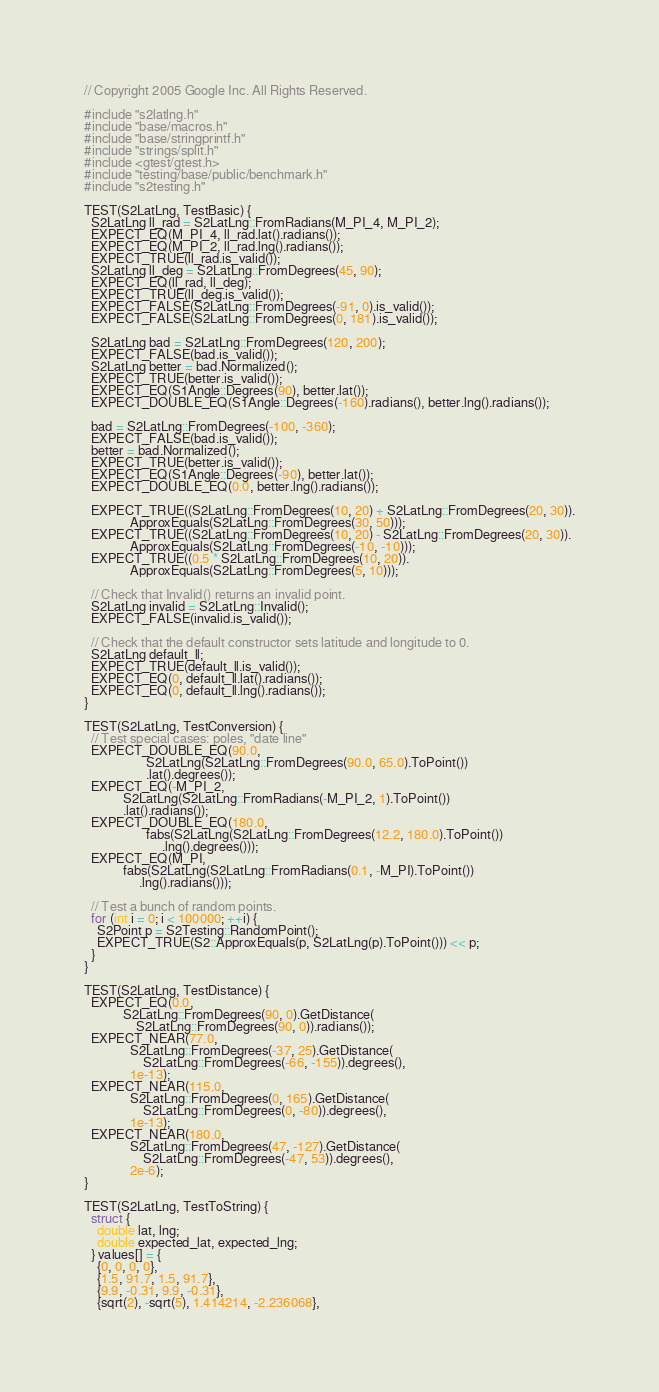Convert code to text. <code><loc_0><loc_0><loc_500><loc_500><_C++_>// Copyright 2005 Google Inc. All Rights Reserved.

#include "s2latlng.h"
#include "base/macros.h"
#include "base/stringprintf.h"
#include "strings/split.h"
#include <gtest/gtest.h>
#include "testing/base/public/benchmark.h"
#include "s2testing.h"

TEST(S2LatLng, TestBasic) {
  S2LatLng ll_rad = S2LatLng::FromRadians(M_PI_4, M_PI_2);
  EXPECT_EQ(M_PI_4, ll_rad.lat().radians());
  EXPECT_EQ(M_PI_2, ll_rad.lng().radians());
  EXPECT_TRUE(ll_rad.is_valid());
  S2LatLng ll_deg = S2LatLng::FromDegrees(45, 90);
  EXPECT_EQ(ll_rad, ll_deg);
  EXPECT_TRUE(ll_deg.is_valid());
  EXPECT_FALSE(S2LatLng::FromDegrees(-91, 0).is_valid());
  EXPECT_FALSE(S2LatLng::FromDegrees(0, 181).is_valid());

  S2LatLng bad = S2LatLng::FromDegrees(120, 200);
  EXPECT_FALSE(bad.is_valid());
  S2LatLng better = bad.Normalized();
  EXPECT_TRUE(better.is_valid());
  EXPECT_EQ(S1Angle::Degrees(90), better.lat());
  EXPECT_DOUBLE_EQ(S1Angle::Degrees(-160).radians(), better.lng().radians());

  bad = S2LatLng::FromDegrees(-100, -360);
  EXPECT_FALSE(bad.is_valid());
  better = bad.Normalized();
  EXPECT_TRUE(better.is_valid());
  EXPECT_EQ(S1Angle::Degrees(-90), better.lat());
  EXPECT_DOUBLE_EQ(0.0, better.lng().radians());

  EXPECT_TRUE((S2LatLng::FromDegrees(10, 20) + S2LatLng::FromDegrees(20, 30)).
              ApproxEquals(S2LatLng::FromDegrees(30, 50)));
  EXPECT_TRUE((S2LatLng::FromDegrees(10, 20) - S2LatLng::FromDegrees(20, 30)).
              ApproxEquals(S2LatLng::FromDegrees(-10, -10)));
  EXPECT_TRUE((0.5 * S2LatLng::FromDegrees(10, 20)).
              ApproxEquals(S2LatLng::FromDegrees(5, 10)));

  // Check that Invalid() returns an invalid point.
  S2LatLng invalid = S2LatLng::Invalid();
  EXPECT_FALSE(invalid.is_valid());

  // Check that the default constructor sets latitude and longitude to 0.
  S2LatLng default_ll;
  EXPECT_TRUE(default_ll.is_valid());
  EXPECT_EQ(0, default_ll.lat().radians());
  EXPECT_EQ(0, default_ll.lng().radians());
}

TEST(S2LatLng, TestConversion) {
  // Test special cases: poles, "date line"
  EXPECT_DOUBLE_EQ(90.0,
                   S2LatLng(S2LatLng::FromDegrees(90.0, 65.0).ToPoint())
                   .lat().degrees());
  EXPECT_EQ(-M_PI_2,
            S2LatLng(S2LatLng::FromRadians(-M_PI_2, 1).ToPoint())
            .lat().radians());
  EXPECT_DOUBLE_EQ(180.0,
                   fabs(S2LatLng(S2LatLng::FromDegrees(12.2, 180.0).ToPoint())
                        .lng().degrees()));
  EXPECT_EQ(M_PI,
            fabs(S2LatLng(S2LatLng::FromRadians(0.1, -M_PI).ToPoint())
                 .lng().radians()));

  // Test a bunch of random points.
  for (int i = 0; i < 100000; ++i) {
    S2Point p = S2Testing::RandomPoint();
    EXPECT_TRUE(S2::ApproxEquals(p, S2LatLng(p).ToPoint())) << p;
  }
}

TEST(S2LatLng, TestDistance) {
  EXPECT_EQ(0.0,
            S2LatLng::FromDegrees(90, 0).GetDistance(
                S2LatLng::FromDegrees(90, 0)).radians());
  EXPECT_NEAR(77.0,
              S2LatLng::FromDegrees(-37, 25).GetDistance(
                  S2LatLng::FromDegrees(-66, -155)).degrees(),
              1e-13);
  EXPECT_NEAR(115.0,
              S2LatLng::FromDegrees(0, 165).GetDistance(
                  S2LatLng::FromDegrees(0, -80)).degrees(),
              1e-13);
  EXPECT_NEAR(180.0,
              S2LatLng::FromDegrees(47, -127).GetDistance(
                  S2LatLng::FromDegrees(-47, 53)).degrees(),
              2e-6);
}

TEST(S2LatLng, TestToString) {
  struct {
    double lat, lng;
    double expected_lat, expected_lng;
  } values[] = {
    {0, 0, 0, 0},
    {1.5, 91.7, 1.5, 91.7},
    {9.9, -0.31, 9.9, -0.31},
    {sqrt(2), -sqrt(5), 1.414214, -2.236068},</code> 